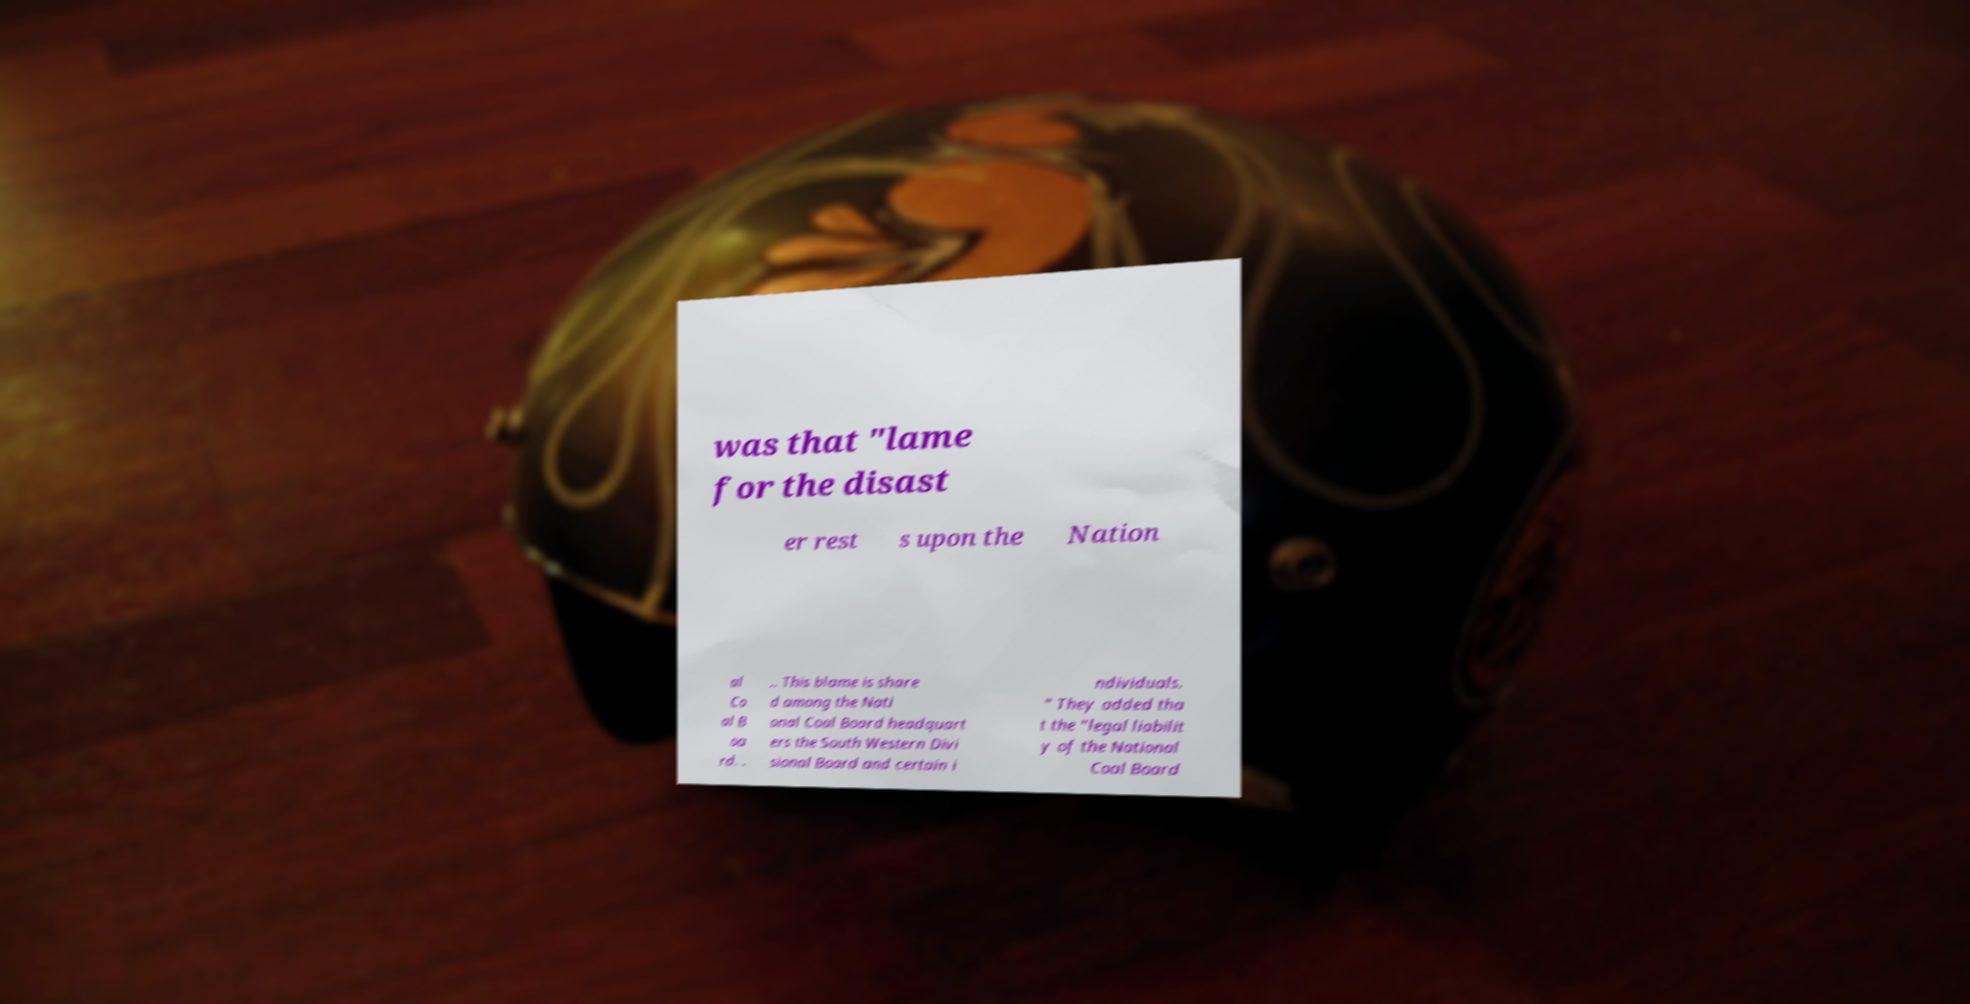What messages or text are displayed in this image? I need them in a readable, typed format. was that "lame for the disast er rest s upon the Nation al Co al B oa rd. . .. This blame is share d among the Nati onal Coal Board headquart ers the South Western Divi sional Board and certain i ndividuals. " They added tha t the "legal liabilit y of the National Coal Board 